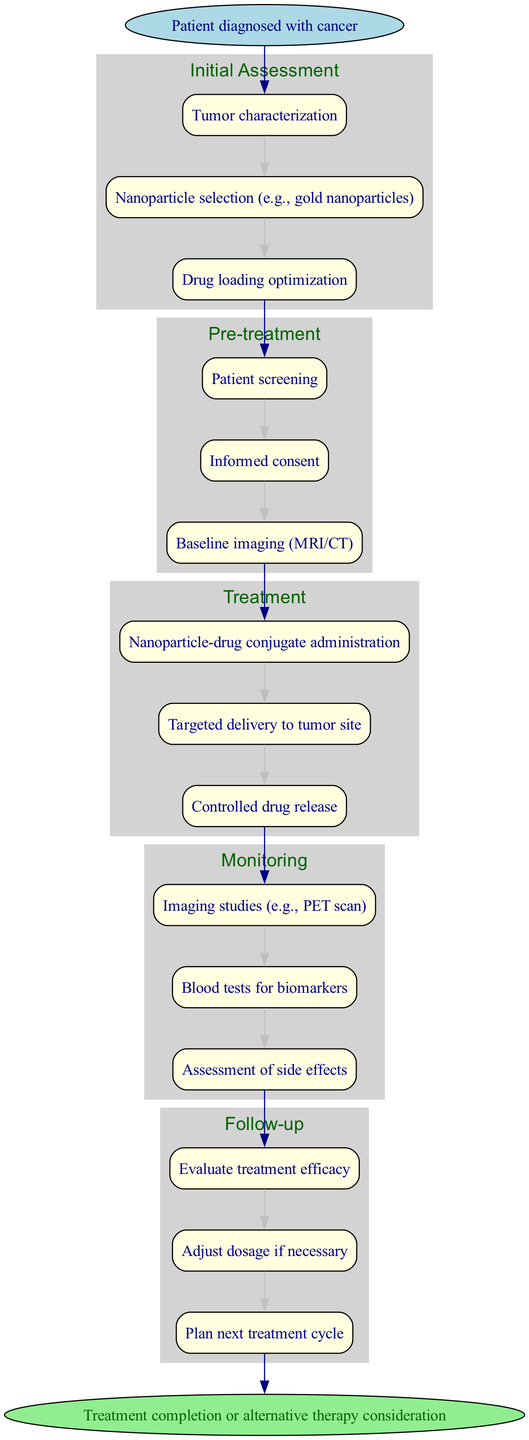What is the start point of the clinical pathway? The start point is clearly labeled in the diagram as "Patient diagnosed with cancer".
Answer: Patient diagnosed with cancer How many stages are there in the clinical pathway? By counting the stages listed in the diagram, we find that there are a total of five stages.
Answer: 5 What is the second step in the "Initial Assessment" stage? Referring to the steps provided under the "Initial Assessment" stage, the second step is "Nanoparticle selection (e.g., gold nanoparticles)".
Answer: Nanoparticle selection (e.g., gold nanoparticles) What is the last step in the "Follow-up" stage? Looking at the "Follow-up" stage, the last step recorded is "Plan next treatment cycle".
Answer: Plan next treatment cycle What type of imaging studies are performed during the "Monitoring" stage? The diagram lists "Imaging studies (e.g., PET scan)" as one of the steps in the "Monitoring" stage.
Answer: Imaging studies (e.g., PET scan) What is the first step in the "Treatment" stage? The diagram specifies that the first step in the "Treatment" stage is "Nanoparticle-drug conjugate administration".
Answer: Nanoparticle-drug conjugate administration How are the stages connected to one another? Each stage connections are illustrated with directed edges, leading from the last step of one stage to the first step of the next stage, indicating a flow from start to end.
Answer: Directional edges What is assessed during the "Monitoring" stage? The steps within the "Monitoring" stage include "Imaging studies", "Blood tests for biomarkers", and "Assessment of side effects" which are all assessed.
Answer: Imaging studies, blood tests for biomarkers, assessment of side effects What option is presented at the end of the clinical pathway? The diagram indicates that the clinical pathway concludes with "Treatment completion or alternative therapy consideration".
Answer: Treatment completion or alternative therapy consideration 